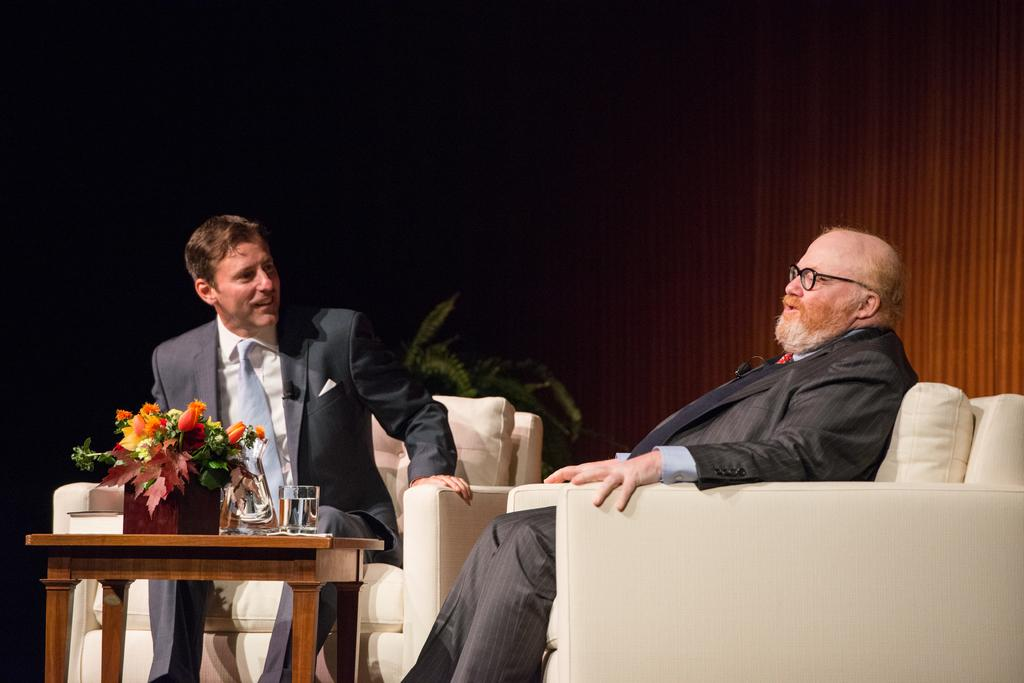How many people are sitting on the couch in the image? There are two people sitting on the couch in the image. What can be seen on the table in the image? There is a flower pot and a glass on the table in the image. What is the hour of the day depicted in the image? The provided facts do not give any information about the time of day, so it cannot be determined from the image. 